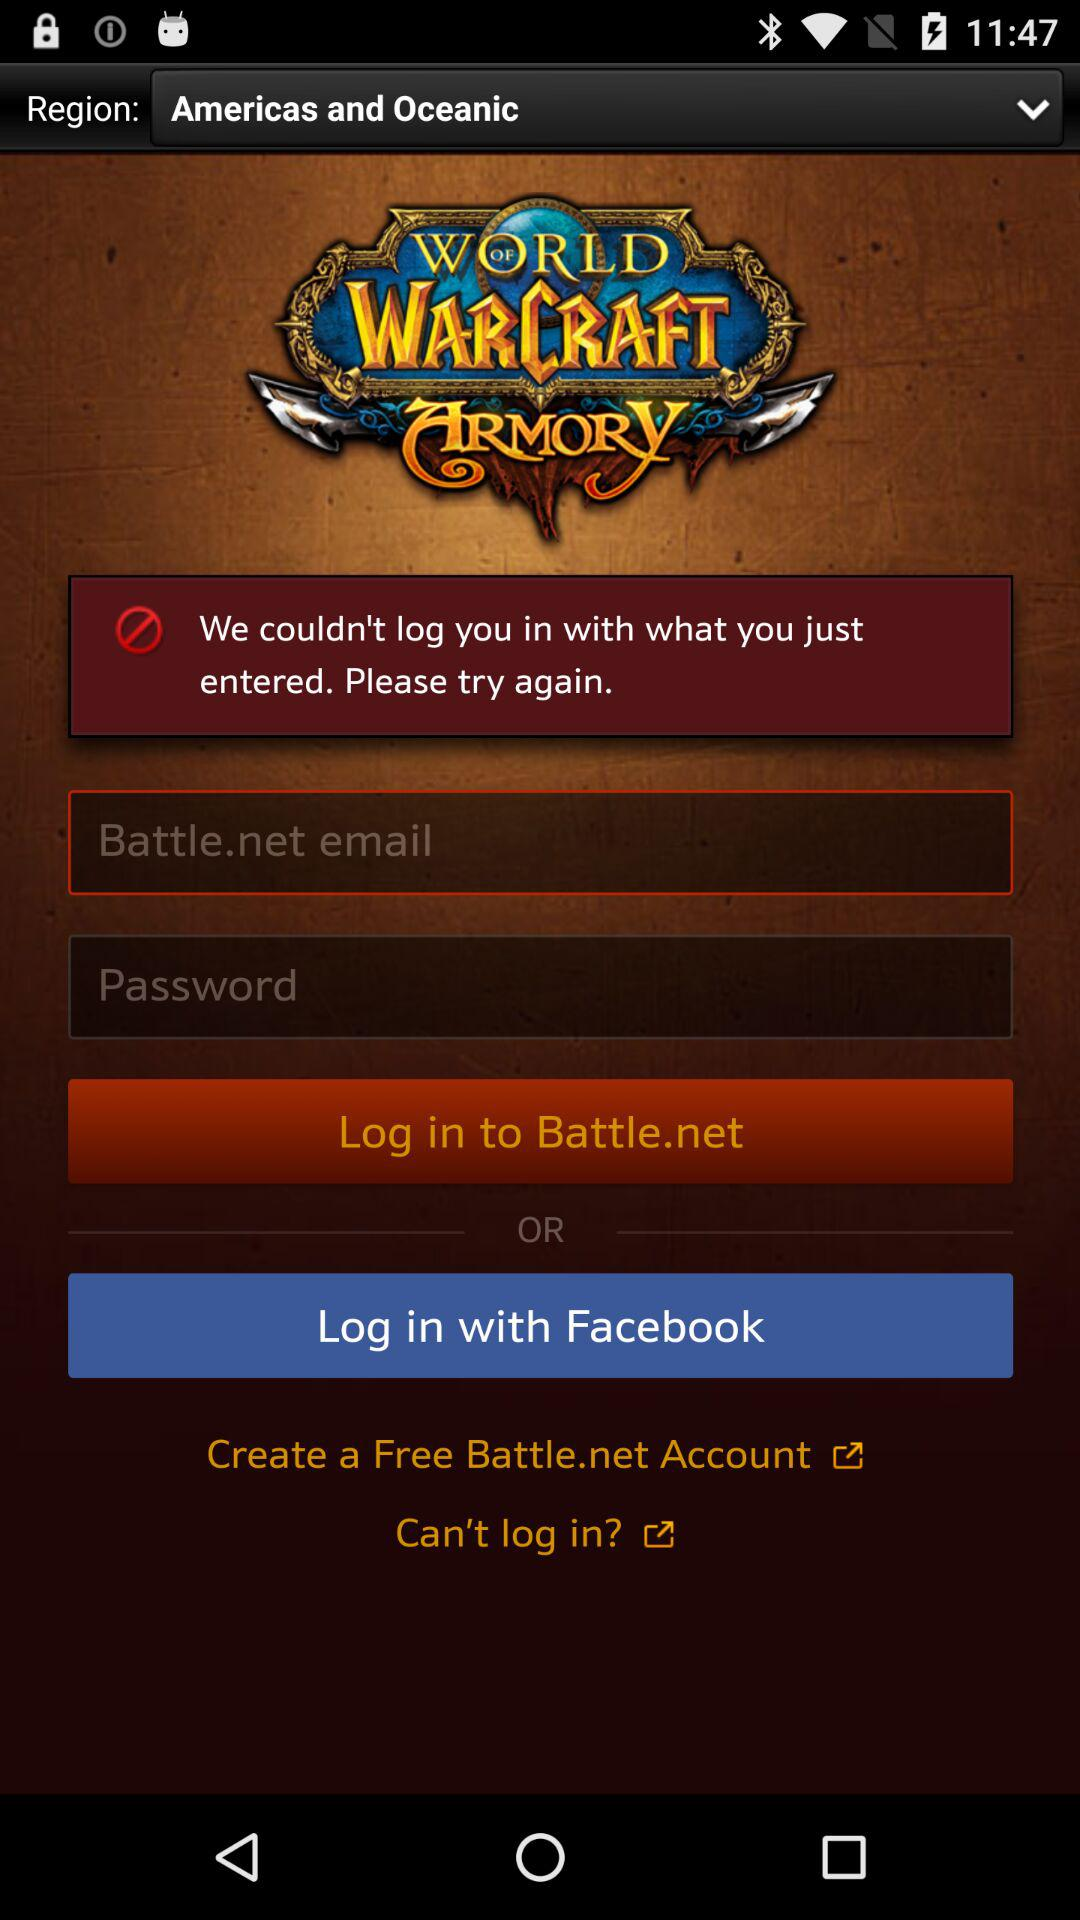What is the selected region? The selected region is "Americas and Oceanic". 